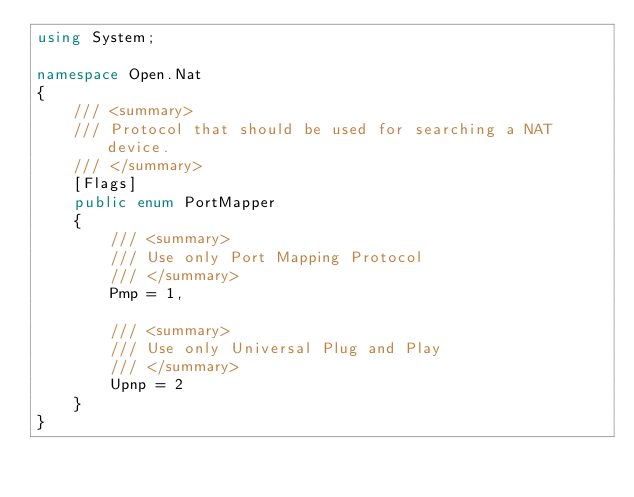<code> <loc_0><loc_0><loc_500><loc_500><_C#_>using System;

namespace Open.Nat
{
	/// <summary>
	/// Protocol that should be used for searching a NAT device. 
	/// </summary>
	[Flags]
	public enum PortMapper
	{
		/// <summary>
		/// Use only Port Mapping Protocol
		/// </summary>
		Pmp = 1,

		/// <summary>
		/// Use only Universal Plug and Play
		/// </summary>
		Upnp = 2
	}
}</code> 